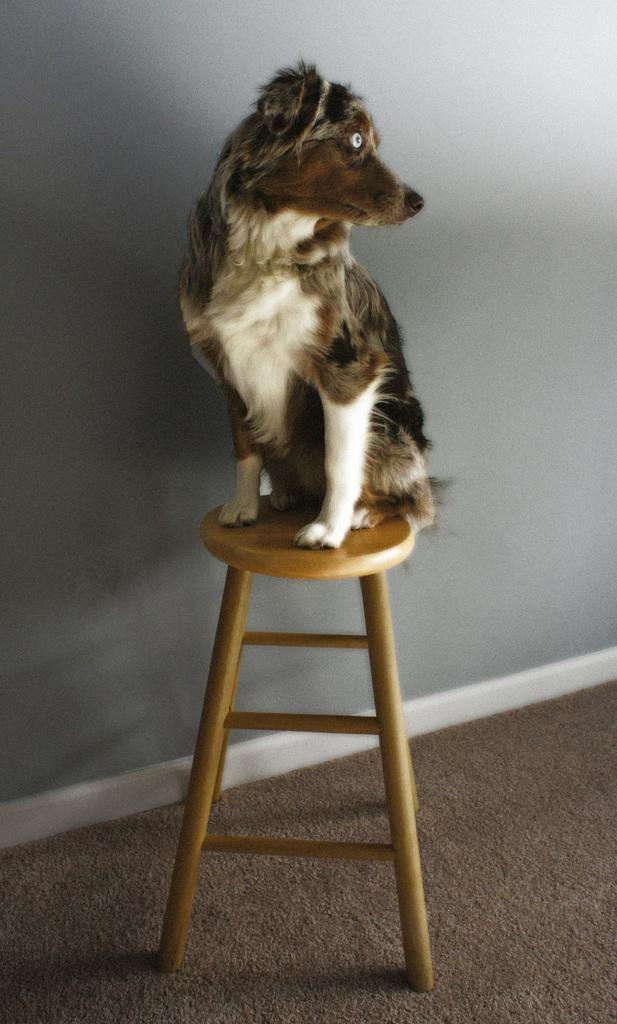What type of animal is in the image? There is a dog in the image. Where is the dog positioned in the image? The dog is on a stool. What can be seen in the background of the image? There is a wall in the background of the image. What is at the bottom of the image? There is a mat at the bottom of the image. Can you tell me how the monkey is kicking the ball in the image? There is no monkey or ball present in the image; it features a dog on a stool. What is the value of the painting hanging on the wall in the image? There is no painting or indication of value mentioned in the image; it only shows a dog on a stool with a wall in the background. 